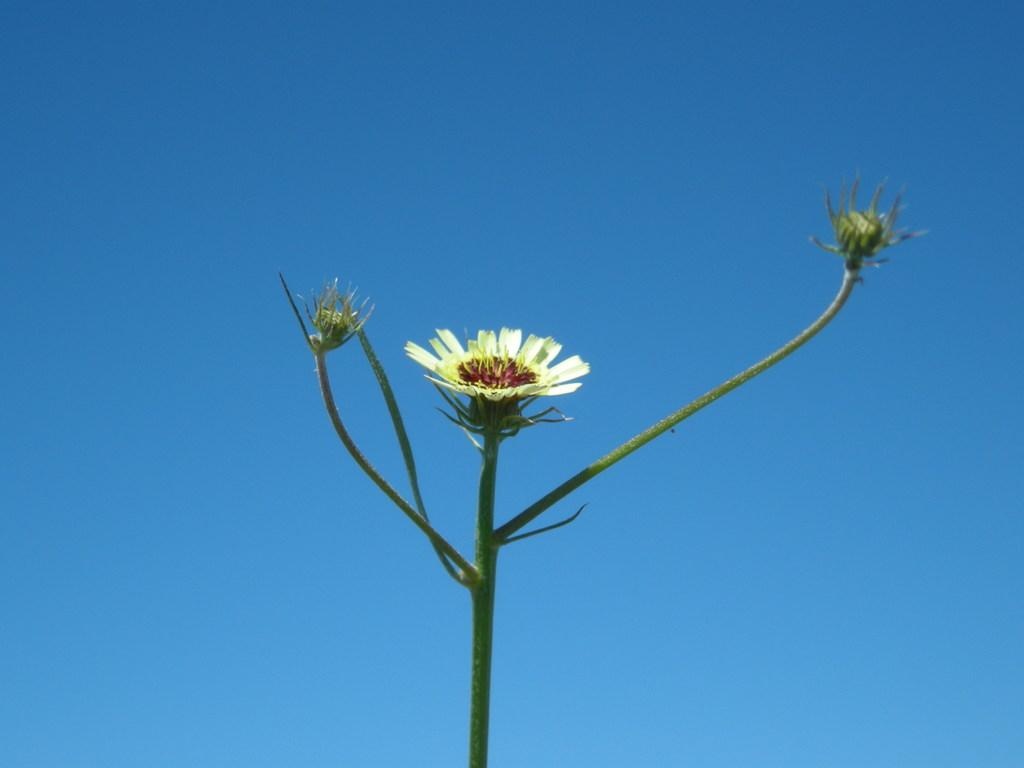What type of flower is in the image? There is a white color flower in the image. What stage of growth is the flower in? The flower has buds. How is the flower attached to the stem? The flower has leaves on a stem. What color is the background of the image? The background of the image is blue. How many facts can be pulled from the image? The term "facts" does not refer to a physical object that can be pulled from the image. The image contains visual information, not facts that can be physically removed. 